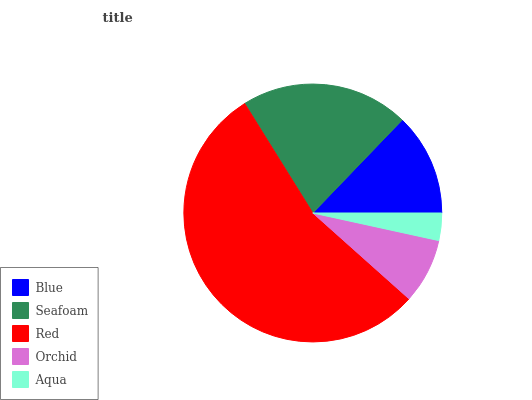Is Aqua the minimum?
Answer yes or no. Yes. Is Red the maximum?
Answer yes or no. Yes. Is Seafoam the minimum?
Answer yes or no. No. Is Seafoam the maximum?
Answer yes or no. No. Is Seafoam greater than Blue?
Answer yes or no. Yes. Is Blue less than Seafoam?
Answer yes or no. Yes. Is Blue greater than Seafoam?
Answer yes or no. No. Is Seafoam less than Blue?
Answer yes or no. No. Is Blue the high median?
Answer yes or no. Yes. Is Blue the low median?
Answer yes or no. Yes. Is Aqua the high median?
Answer yes or no. No. Is Orchid the low median?
Answer yes or no. No. 